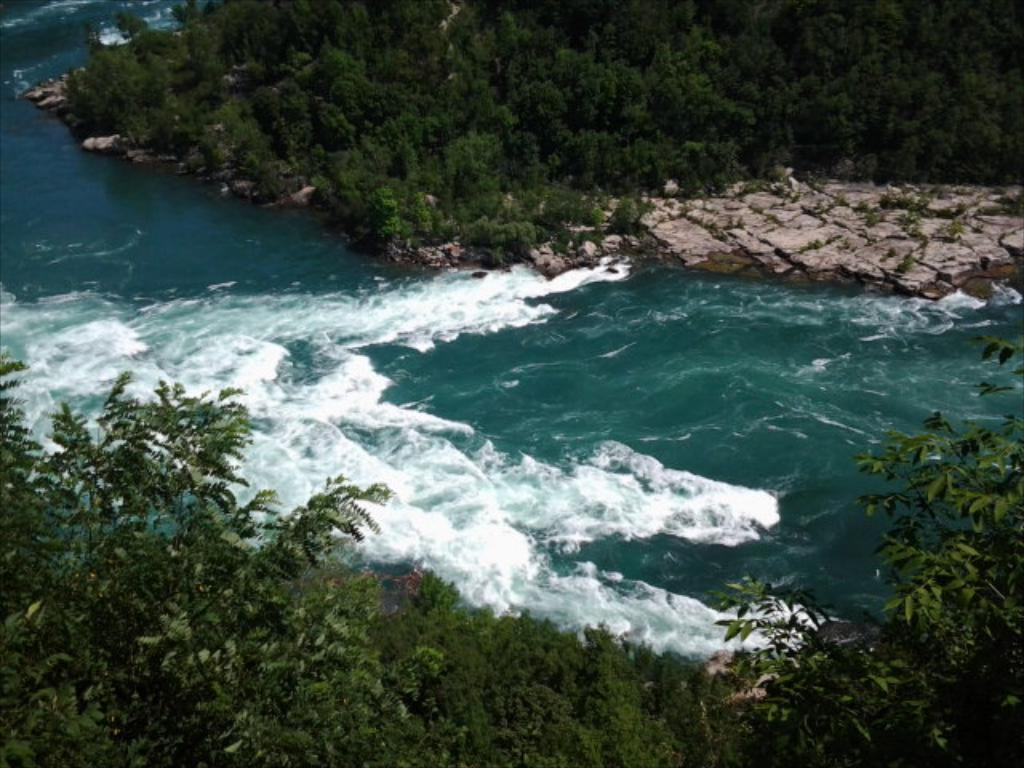What type of natural feature is present in the image? There is a river in the image. What can be seen on the sides of the river? There are trees on the sides of the river. What other objects or features can be seen in the image? There are rocks in the image. What type of insurance policy is being discussed in the image? There is no discussion or mention of insurance in the image; it features a river, trees, and rocks. 